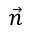Convert formula to latex. <formula><loc_0><loc_0><loc_500><loc_500>\vec { n }</formula> 